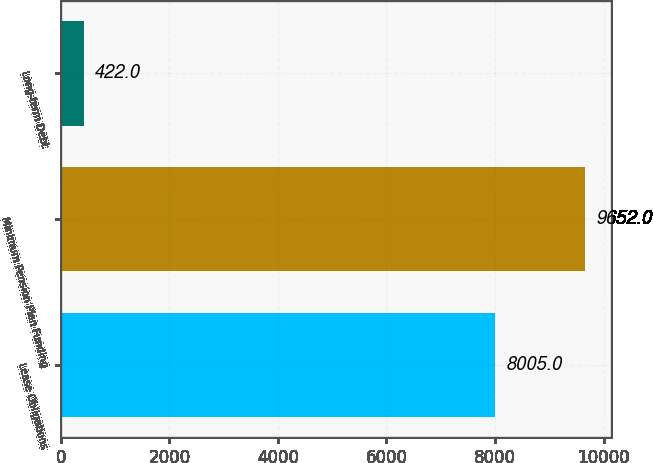Convert chart to OTSL. <chart><loc_0><loc_0><loc_500><loc_500><bar_chart><fcel>Lease Obligations<fcel>Minimum Pension Plan Funding<fcel>Long-term Debt<nl><fcel>8005<fcel>9652<fcel>422<nl></chart> 